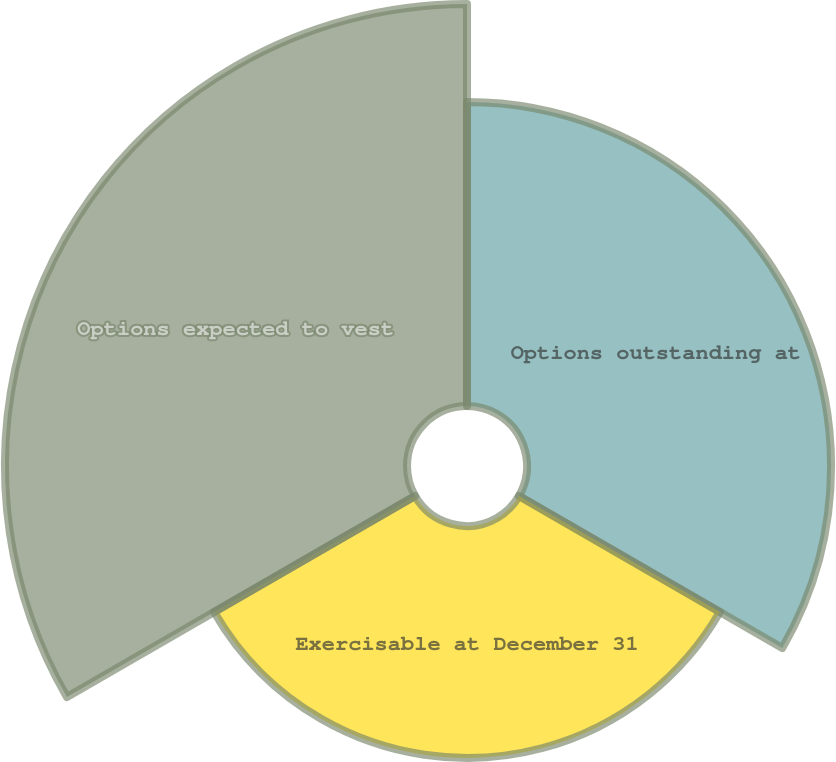<chart> <loc_0><loc_0><loc_500><loc_500><pie_chart><fcel>Options outstanding at<fcel>Exercisable at December 31<fcel>Options expected to vest<nl><fcel>32.42%<fcel>24.73%<fcel>42.86%<nl></chart> 